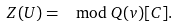<formula> <loc_0><loc_0><loc_500><loc_500>Z ( U ) = \mod Q ( v ) [ C ] .</formula> 